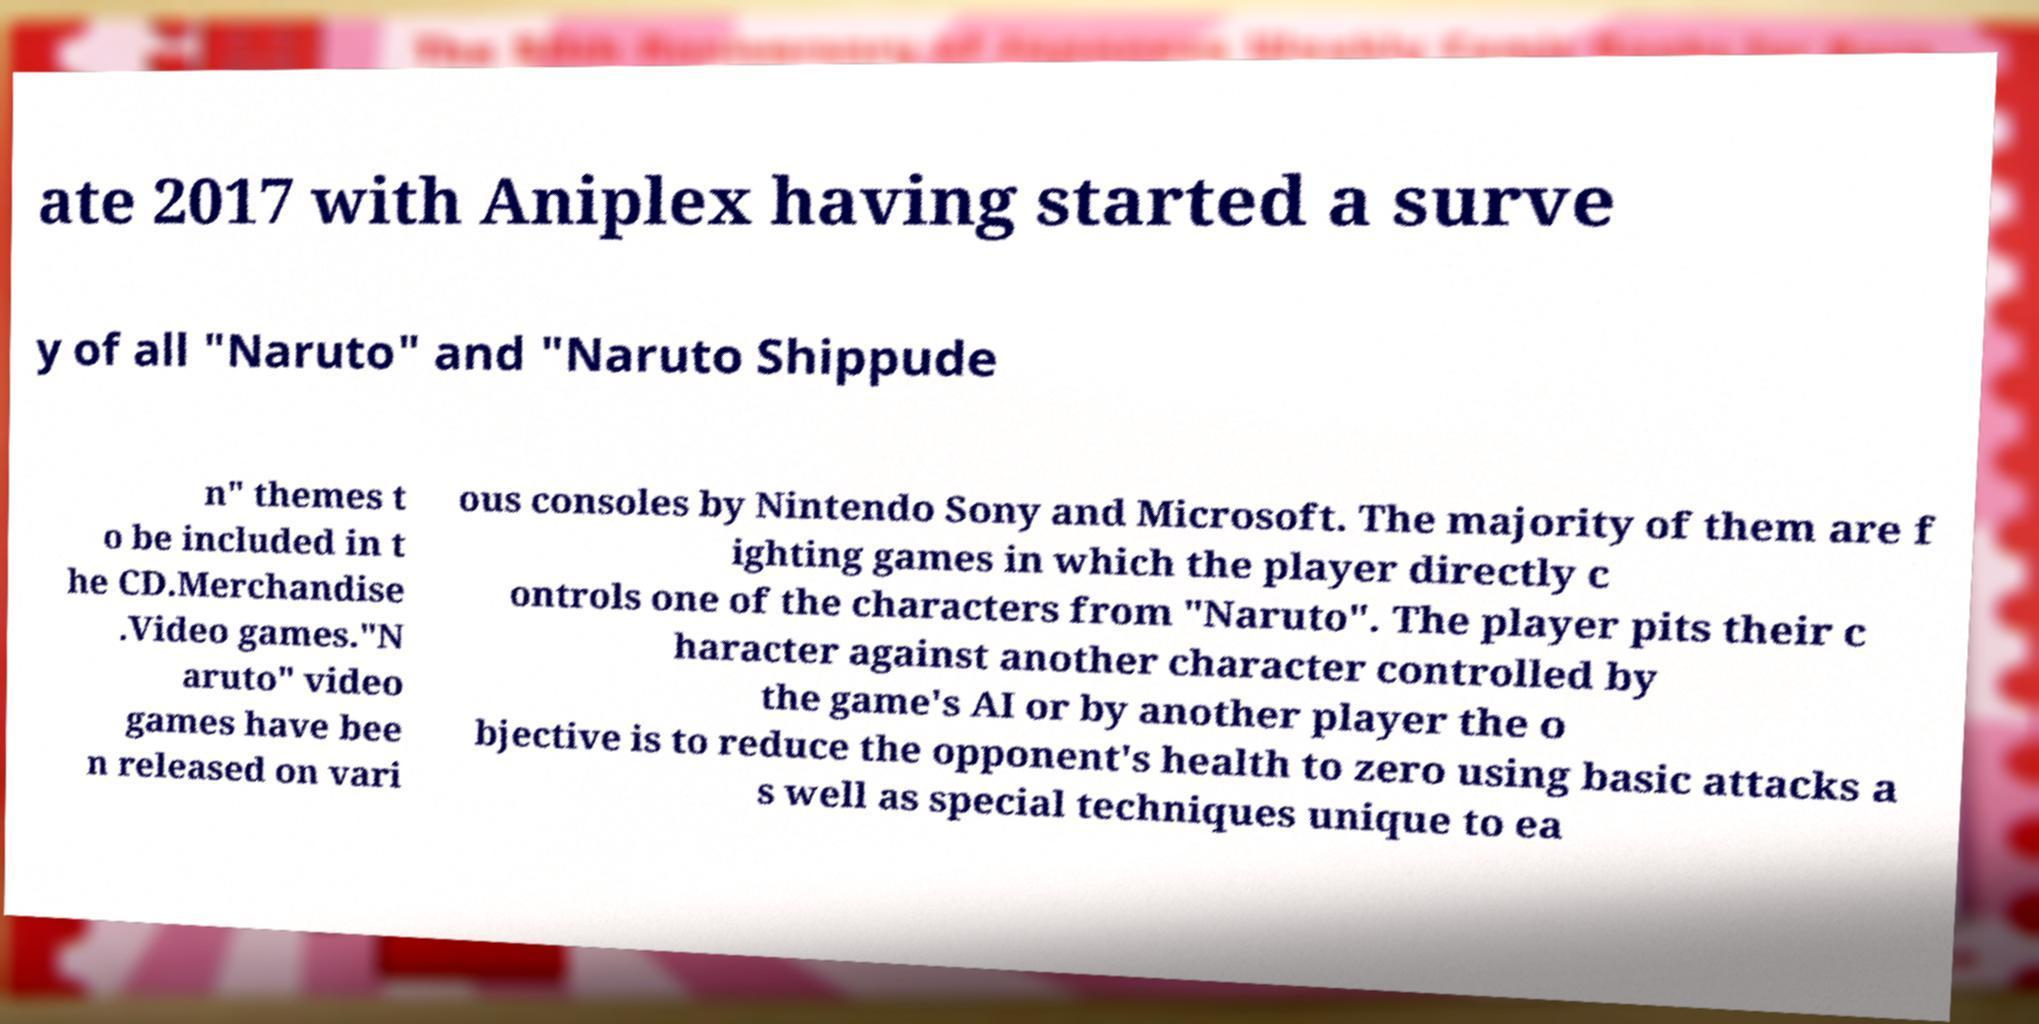Please read and relay the text visible in this image. What does it say? ate 2017 with Aniplex having started a surve y of all "Naruto" and "Naruto Shippude n" themes t o be included in t he CD.Merchandise .Video games."N aruto" video games have bee n released on vari ous consoles by Nintendo Sony and Microsoft. The majority of them are f ighting games in which the player directly c ontrols one of the characters from "Naruto". The player pits their c haracter against another character controlled by the game's AI or by another player the o bjective is to reduce the opponent's health to zero using basic attacks a s well as special techniques unique to ea 